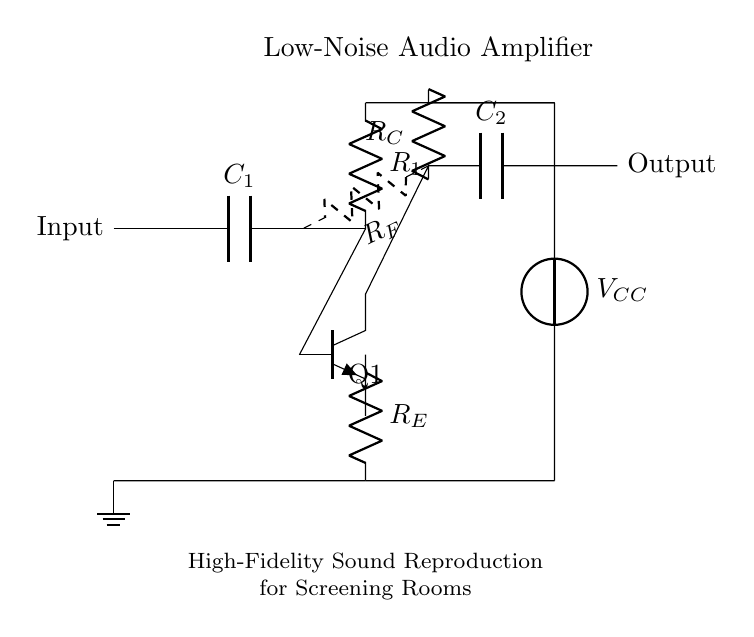What is the type of the main amplification component? The main amplification component in the circuit is a transistor, indicated by the label "Q1" and the npn type symbol.
Answer: transistor What is the function of capacitor C1? Capacitor C1 serves as an input coupling capacitor, allowing AC signals to enter while blocking DC components.
Answer: input coupling What does the resistor R_E do in this circuit? Resistor R_E is used for emitter biasing, which helps improve the linearity and stability of the transistor's operation.
Answer: emitter biasing What is the value of the supply voltage indicated in the circuit? The supply voltage, represented by V_CC, connects to various parts of the circuit to provide power. Its specific value is not given in the diagram.
Answer: unspecified How is feedback implemented in this audio amplifier circuit? Feedback is implemented through resistor R_F, which connects the output to the input, enhancing stability and reducing distortion.
Answer: feedback resistor What does capacitor C2 do? Capacitor C2 is used for output coupling, allowing the amplified AC signal to pass while blocking any DC voltage present at the output.
Answer: output coupling 